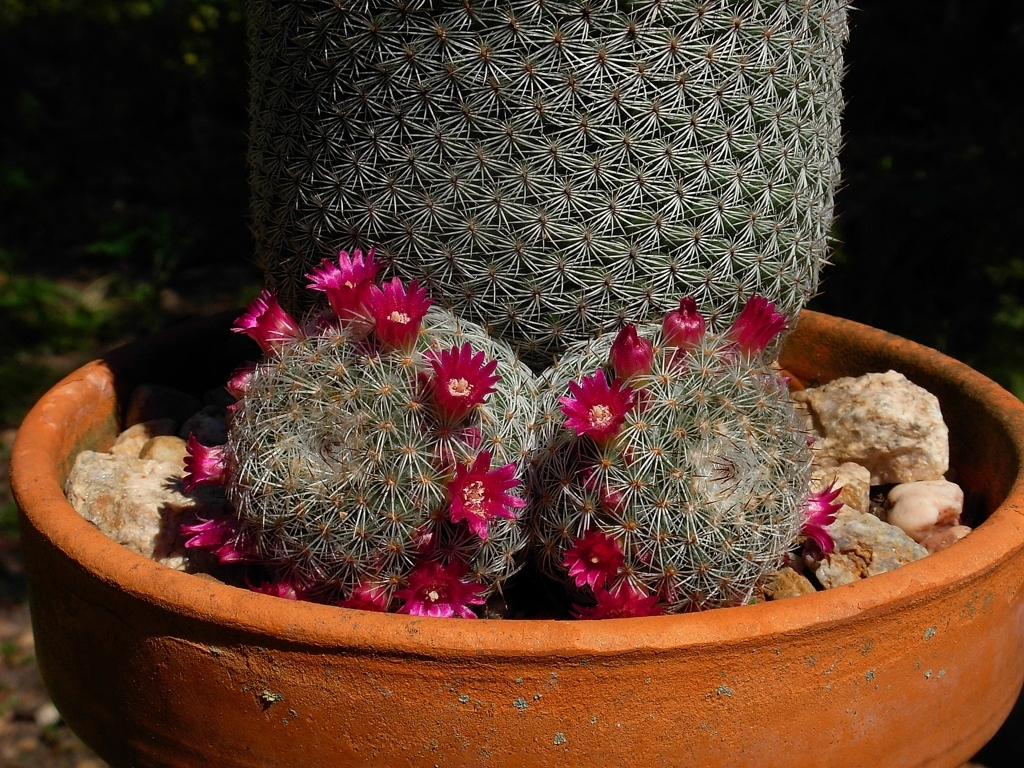Is the texture of the flower petals clear? Yes, the texture of the flower petals is indeed clear, with each petal's delicate surface and vibrant magenta color distinctly visible against the cactus's sharp spines. 